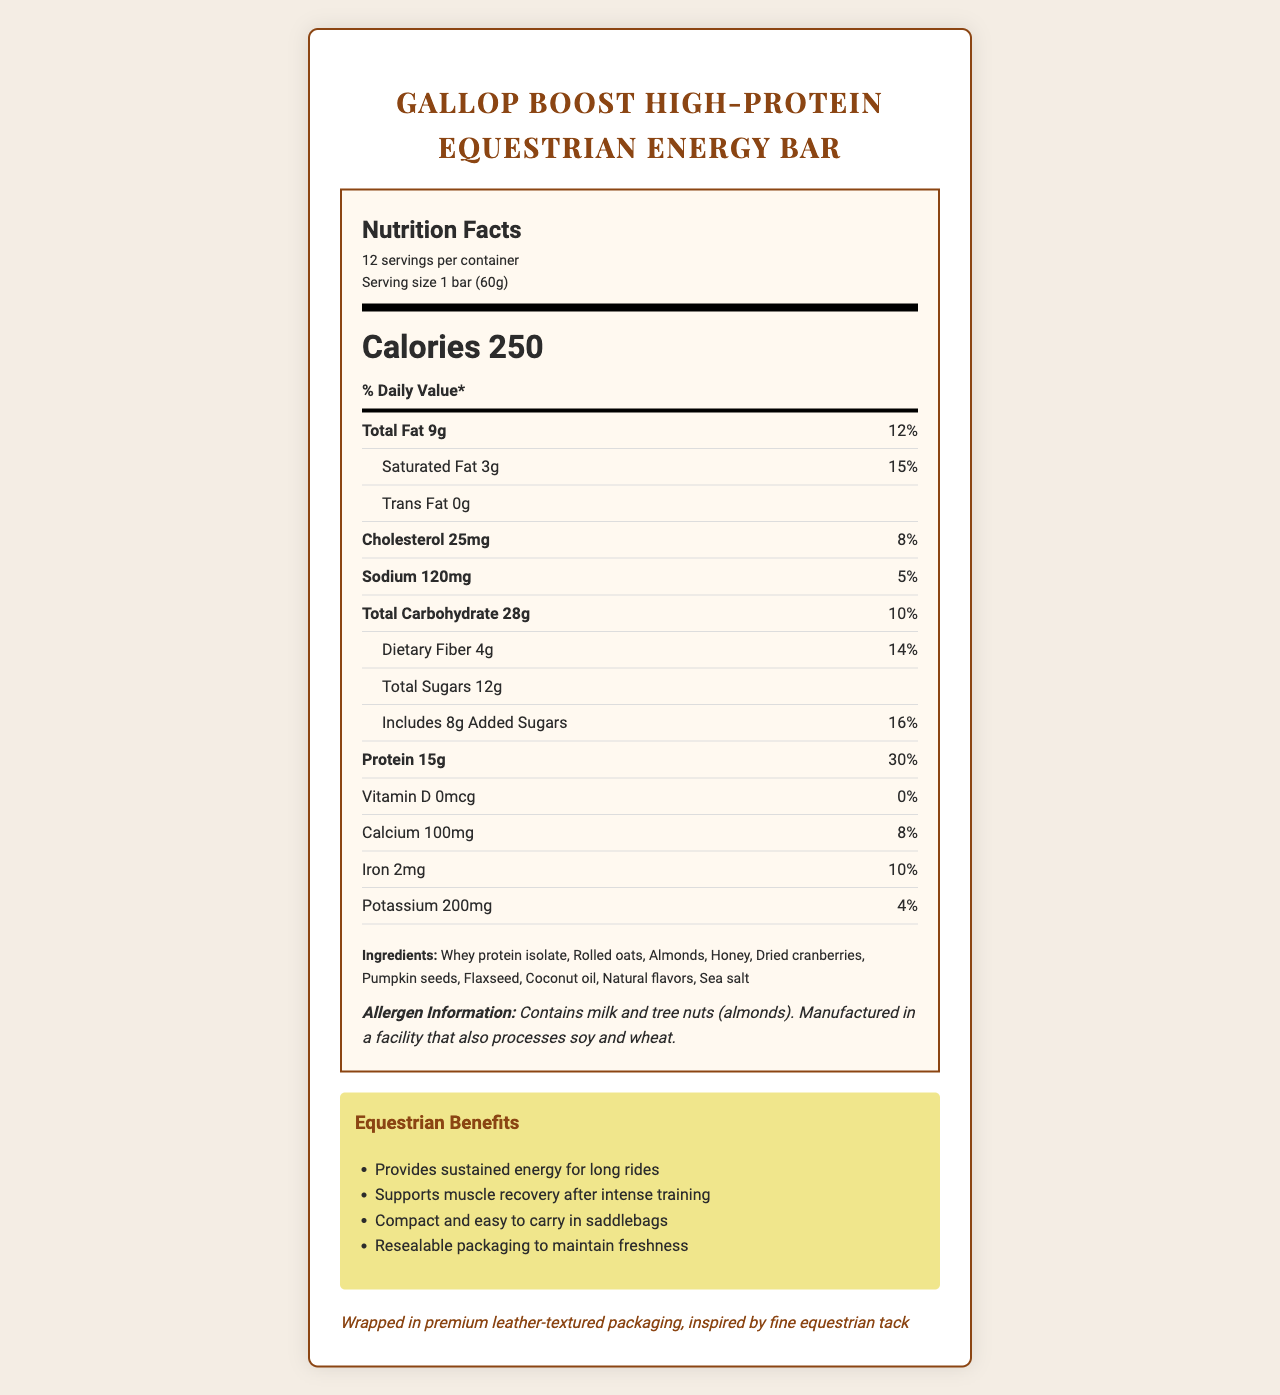How many calories are in one bar? The document lists the calorie content as “Calories 250” under the Nutrition Facts section.
Answer: 250 calories What is the serving size for the Gallop Boost High-Protein Equestrian Energy Bar? The document states the serving size is "1 bar (60g)" right under the product name.
Answer: 1 bar (60g) How much protein is in each serving, and what percentage of the daily value does this represent? The document specifies "Protein 15g" and "30%" under the % Daily Value section in the Nutrition Facts.
Answer: 15g, 30% Name three ingredients in the Gallop Boost High-Protein Equestrian Energy Bar. The ingredient list includes "Whey protein isolate, Rolled oats, Almonds" among others.
Answer: Whey protein isolate, Rolled oats, Almonds What are the storage instructions for this product? The storage instructions are provided at the end of the document.
Answer: Store in a cool, dry place. For best freshness, consume within 2 weeks of opening. How much added sugar is included in the bar? The document lists added sugars as "Includes 8g Added Sugars" under the sub-nutrient section.
Answer: 8g Which of the following benefits is NOT mentioned in the document for equestrian use? A. Provides quick energy for short rides B. Supports muscle recovery after intense training C. Compact and easy to carry in saddlebags The document lists benefits for long rides, muscle recovery, easy to carry in saddlebags, and resealable packaging. Quick energy for short rides is not mentioned.
Answer: A How many servings are there per container? A. 10 B. 11 C. 12 D. 13 The document mentions there are "12 servings per container."
Answer: C. 12 Does the bar contain any tree nuts? The allergen information states "Contains milk and tree nuts (almonds)."
Answer: Yes Summarize the main idea of the document. The document encompasses multiple sections like nutritional facts, ingredient list, storage instructions, allergen information, and specific benefits for equestrians to give a complete overview of the product.
Answer: The document provides detailed nutritional information, ingredients, allergen information, storage instructions, and equestrian benefits for the Gallop Boost High-Protein Equestrian Energy Bar, wrapped in premium leather-textured packaging inspired by equestrian tack. What is the amount of vitamin D in this energy bar? The document lists vitamin D as "0mcg" under the nutritional facts section.
Answer: 0mcg What is the total amount of dietary fiber per serving? The document specifies "Dietary Fiber 4g" under the sub-nutrient section.
Answer: 4g How much sodium is there per serving, and what percentage of the daily value does it represent? The document specifies "Sodium 120mg" and "5%" under the % Daily Value section in the Nutrition Facts.
Answer: 120mg, 5% What is the daily value percentage of iron in this energy bar? The document specifies "Iron 10%" under the % Daily Value section.
Answer: 10% Is the bar contains artificial colors or flavors? The document lists "Natural flavors", but it does not mention artificial colors or flavors explicitly.
Answer: Not enough information What is the unique packaging feature mentioned? The document mentions a "premium leather-textured packaging, inspired by fine equestrian tack" at the end.
Answer: Wrapped in premium leather-textured packaging 